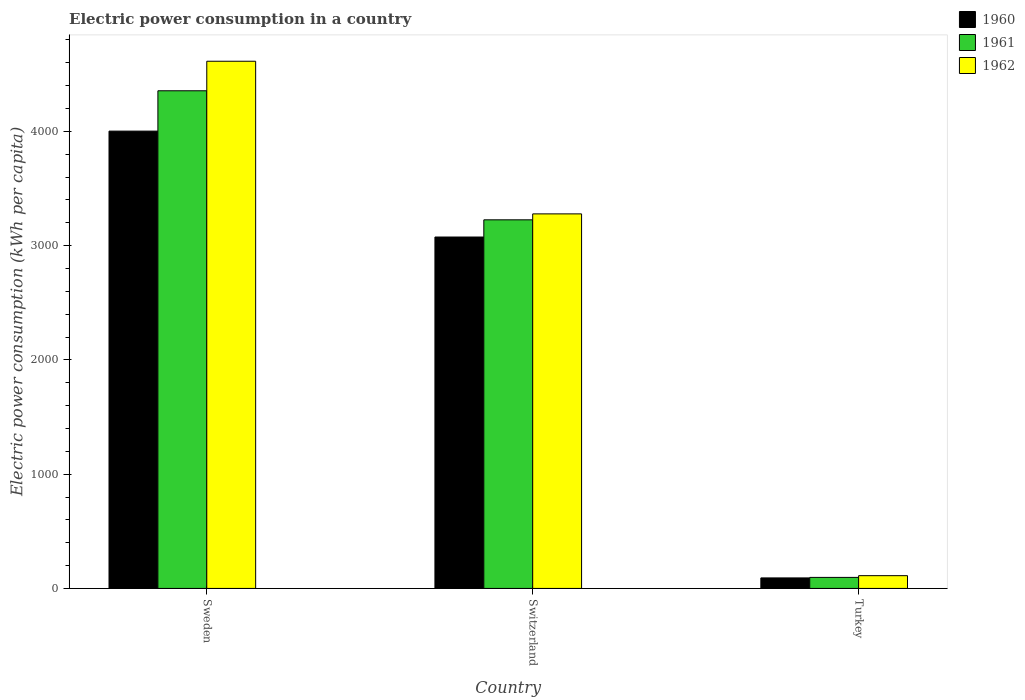How many groups of bars are there?
Your answer should be compact. 3. Are the number of bars per tick equal to the number of legend labels?
Your response must be concise. Yes. Are the number of bars on each tick of the X-axis equal?
Your answer should be very brief. Yes. How many bars are there on the 2nd tick from the right?
Give a very brief answer. 3. What is the electric power consumption in in 1962 in Turkey?
Give a very brief answer. 111.76. Across all countries, what is the maximum electric power consumption in in 1961?
Ensure brevity in your answer.  4355.45. Across all countries, what is the minimum electric power consumption in in 1960?
Offer a terse response. 92.04. In which country was the electric power consumption in in 1960 maximum?
Give a very brief answer. Sweden. In which country was the electric power consumption in in 1961 minimum?
Your answer should be very brief. Turkey. What is the total electric power consumption in in 1960 in the graph?
Keep it short and to the point. 7169.91. What is the difference between the electric power consumption in in 1960 in Sweden and that in Switzerland?
Your answer should be very brief. 926.77. What is the difference between the electric power consumption in in 1961 in Turkey and the electric power consumption in in 1962 in Sweden?
Your answer should be compact. -4517.34. What is the average electric power consumption in in 1961 per country?
Offer a very short reply. 2559.36. What is the difference between the electric power consumption in of/in 1960 and electric power consumption in of/in 1961 in Switzerland?
Provide a succinct answer. -150.44. In how many countries, is the electric power consumption in in 1960 greater than 400 kWh per capita?
Offer a terse response. 2. What is the ratio of the electric power consumption in in 1960 in Sweden to that in Turkey?
Your answer should be very brief. 43.48. Is the difference between the electric power consumption in in 1960 in Sweden and Turkey greater than the difference between the electric power consumption in in 1961 in Sweden and Turkey?
Offer a very short reply. No. What is the difference between the highest and the second highest electric power consumption in in 1960?
Your answer should be compact. 926.77. What is the difference between the highest and the lowest electric power consumption in in 1962?
Ensure brevity in your answer.  4502.22. In how many countries, is the electric power consumption in in 1961 greater than the average electric power consumption in in 1961 taken over all countries?
Your answer should be very brief. 2. Is the sum of the electric power consumption in in 1962 in Switzerland and Turkey greater than the maximum electric power consumption in in 1960 across all countries?
Give a very brief answer. No. Is it the case that in every country, the sum of the electric power consumption in in 1960 and electric power consumption in in 1961 is greater than the electric power consumption in in 1962?
Offer a terse response. Yes. How many bars are there?
Your response must be concise. 9. What is the difference between two consecutive major ticks on the Y-axis?
Keep it short and to the point. 1000. Does the graph contain any zero values?
Your answer should be compact. No. Does the graph contain grids?
Give a very brief answer. No. Where does the legend appear in the graph?
Keep it short and to the point. Top right. How many legend labels are there?
Provide a succinct answer. 3. How are the legend labels stacked?
Give a very brief answer. Vertical. What is the title of the graph?
Your answer should be compact. Electric power consumption in a country. What is the label or title of the X-axis?
Your answer should be very brief. Country. What is the label or title of the Y-axis?
Give a very brief answer. Electric power consumption (kWh per capita). What is the Electric power consumption (kWh per capita) of 1960 in Sweden?
Ensure brevity in your answer.  4002.32. What is the Electric power consumption (kWh per capita) of 1961 in Sweden?
Provide a succinct answer. 4355.45. What is the Electric power consumption (kWh per capita) in 1962 in Sweden?
Your answer should be compact. 4613.98. What is the Electric power consumption (kWh per capita) of 1960 in Switzerland?
Your answer should be compact. 3075.55. What is the Electric power consumption (kWh per capita) in 1961 in Switzerland?
Provide a succinct answer. 3225.99. What is the Electric power consumption (kWh per capita) in 1962 in Switzerland?
Provide a succinct answer. 3278.01. What is the Electric power consumption (kWh per capita) of 1960 in Turkey?
Your response must be concise. 92.04. What is the Electric power consumption (kWh per capita) in 1961 in Turkey?
Your answer should be very brief. 96.64. What is the Electric power consumption (kWh per capita) of 1962 in Turkey?
Offer a very short reply. 111.76. Across all countries, what is the maximum Electric power consumption (kWh per capita) of 1960?
Offer a very short reply. 4002.32. Across all countries, what is the maximum Electric power consumption (kWh per capita) in 1961?
Give a very brief answer. 4355.45. Across all countries, what is the maximum Electric power consumption (kWh per capita) in 1962?
Your answer should be compact. 4613.98. Across all countries, what is the minimum Electric power consumption (kWh per capita) of 1960?
Give a very brief answer. 92.04. Across all countries, what is the minimum Electric power consumption (kWh per capita) in 1961?
Your answer should be compact. 96.64. Across all countries, what is the minimum Electric power consumption (kWh per capita) in 1962?
Your response must be concise. 111.76. What is the total Electric power consumption (kWh per capita) of 1960 in the graph?
Offer a terse response. 7169.91. What is the total Electric power consumption (kWh per capita) in 1961 in the graph?
Provide a short and direct response. 7678.08. What is the total Electric power consumption (kWh per capita) in 1962 in the graph?
Provide a succinct answer. 8003.74. What is the difference between the Electric power consumption (kWh per capita) of 1960 in Sweden and that in Switzerland?
Offer a very short reply. 926.77. What is the difference between the Electric power consumption (kWh per capita) in 1961 in Sweden and that in Switzerland?
Provide a succinct answer. 1129.46. What is the difference between the Electric power consumption (kWh per capita) of 1962 in Sweden and that in Switzerland?
Give a very brief answer. 1335.97. What is the difference between the Electric power consumption (kWh per capita) in 1960 in Sweden and that in Turkey?
Give a very brief answer. 3910.28. What is the difference between the Electric power consumption (kWh per capita) in 1961 in Sweden and that in Turkey?
Your answer should be very brief. 4258.82. What is the difference between the Electric power consumption (kWh per capita) in 1962 in Sweden and that in Turkey?
Your answer should be very brief. 4502.22. What is the difference between the Electric power consumption (kWh per capita) in 1960 in Switzerland and that in Turkey?
Keep it short and to the point. 2983.51. What is the difference between the Electric power consumption (kWh per capita) of 1961 in Switzerland and that in Turkey?
Provide a short and direct response. 3129.36. What is the difference between the Electric power consumption (kWh per capita) in 1962 in Switzerland and that in Turkey?
Offer a very short reply. 3166.25. What is the difference between the Electric power consumption (kWh per capita) of 1960 in Sweden and the Electric power consumption (kWh per capita) of 1961 in Switzerland?
Your answer should be compact. 776.33. What is the difference between the Electric power consumption (kWh per capita) in 1960 in Sweden and the Electric power consumption (kWh per capita) in 1962 in Switzerland?
Ensure brevity in your answer.  724.32. What is the difference between the Electric power consumption (kWh per capita) of 1961 in Sweden and the Electric power consumption (kWh per capita) of 1962 in Switzerland?
Make the answer very short. 1077.45. What is the difference between the Electric power consumption (kWh per capita) in 1960 in Sweden and the Electric power consumption (kWh per capita) in 1961 in Turkey?
Offer a terse response. 3905.68. What is the difference between the Electric power consumption (kWh per capita) in 1960 in Sweden and the Electric power consumption (kWh per capita) in 1962 in Turkey?
Offer a very short reply. 3890.56. What is the difference between the Electric power consumption (kWh per capita) in 1961 in Sweden and the Electric power consumption (kWh per capita) in 1962 in Turkey?
Make the answer very short. 4243.69. What is the difference between the Electric power consumption (kWh per capita) of 1960 in Switzerland and the Electric power consumption (kWh per capita) of 1961 in Turkey?
Your answer should be compact. 2978.91. What is the difference between the Electric power consumption (kWh per capita) in 1960 in Switzerland and the Electric power consumption (kWh per capita) in 1962 in Turkey?
Your answer should be compact. 2963.79. What is the difference between the Electric power consumption (kWh per capita) in 1961 in Switzerland and the Electric power consumption (kWh per capita) in 1962 in Turkey?
Provide a succinct answer. 3114.23. What is the average Electric power consumption (kWh per capita) in 1960 per country?
Keep it short and to the point. 2389.97. What is the average Electric power consumption (kWh per capita) of 1961 per country?
Offer a very short reply. 2559.36. What is the average Electric power consumption (kWh per capita) in 1962 per country?
Ensure brevity in your answer.  2667.91. What is the difference between the Electric power consumption (kWh per capita) in 1960 and Electric power consumption (kWh per capita) in 1961 in Sweden?
Provide a short and direct response. -353.13. What is the difference between the Electric power consumption (kWh per capita) of 1960 and Electric power consumption (kWh per capita) of 1962 in Sweden?
Offer a terse response. -611.66. What is the difference between the Electric power consumption (kWh per capita) of 1961 and Electric power consumption (kWh per capita) of 1962 in Sweden?
Your answer should be compact. -258.52. What is the difference between the Electric power consumption (kWh per capita) in 1960 and Electric power consumption (kWh per capita) in 1961 in Switzerland?
Offer a terse response. -150.44. What is the difference between the Electric power consumption (kWh per capita) in 1960 and Electric power consumption (kWh per capita) in 1962 in Switzerland?
Your answer should be compact. -202.46. What is the difference between the Electric power consumption (kWh per capita) in 1961 and Electric power consumption (kWh per capita) in 1962 in Switzerland?
Provide a succinct answer. -52.01. What is the difference between the Electric power consumption (kWh per capita) in 1960 and Electric power consumption (kWh per capita) in 1961 in Turkey?
Give a very brief answer. -4.6. What is the difference between the Electric power consumption (kWh per capita) of 1960 and Electric power consumption (kWh per capita) of 1962 in Turkey?
Give a very brief answer. -19.72. What is the difference between the Electric power consumption (kWh per capita) in 1961 and Electric power consumption (kWh per capita) in 1962 in Turkey?
Provide a succinct answer. -15.12. What is the ratio of the Electric power consumption (kWh per capita) of 1960 in Sweden to that in Switzerland?
Offer a terse response. 1.3. What is the ratio of the Electric power consumption (kWh per capita) of 1961 in Sweden to that in Switzerland?
Give a very brief answer. 1.35. What is the ratio of the Electric power consumption (kWh per capita) of 1962 in Sweden to that in Switzerland?
Your answer should be very brief. 1.41. What is the ratio of the Electric power consumption (kWh per capita) in 1960 in Sweden to that in Turkey?
Your answer should be very brief. 43.48. What is the ratio of the Electric power consumption (kWh per capita) of 1961 in Sweden to that in Turkey?
Offer a very short reply. 45.07. What is the ratio of the Electric power consumption (kWh per capita) of 1962 in Sweden to that in Turkey?
Provide a succinct answer. 41.28. What is the ratio of the Electric power consumption (kWh per capita) in 1960 in Switzerland to that in Turkey?
Your response must be concise. 33.42. What is the ratio of the Electric power consumption (kWh per capita) in 1961 in Switzerland to that in Turkey?
Give a very brief answer. 33.38. What is the ratio of the Electric power consumption (kWh per capita) of 1962 in Switzerland to that in Turkey?
Your response must be concise. 29.33. What is the difference between the highest and the second highest Electric power consumption (kWh per capita) in 1960?
Offer a very short reply. 926.77. What is the difference between the highest and the second highest Electric power consumption (kWh per capita) of 1961?
Provide a succinct answer. 1129.46. What is the difference between the highest and the second highest Electric power consumption (kWh per capita) of 1962?
Keep it short and to the point. 1335.97. What is the difference between the highest and the lowest Electric power consumption (kWh per capita) of 1960?
Make the answer very short. 3910.28. What is the difference between the highest and the lowest Electric power consumption (kWh per capita) of 1961?
Your answer should be compact. 4258.82. What is the difference between the highest and the lowest Electric power consumption (kWh per capita) of 1962?
Offer a very short reply. 4502.22. 